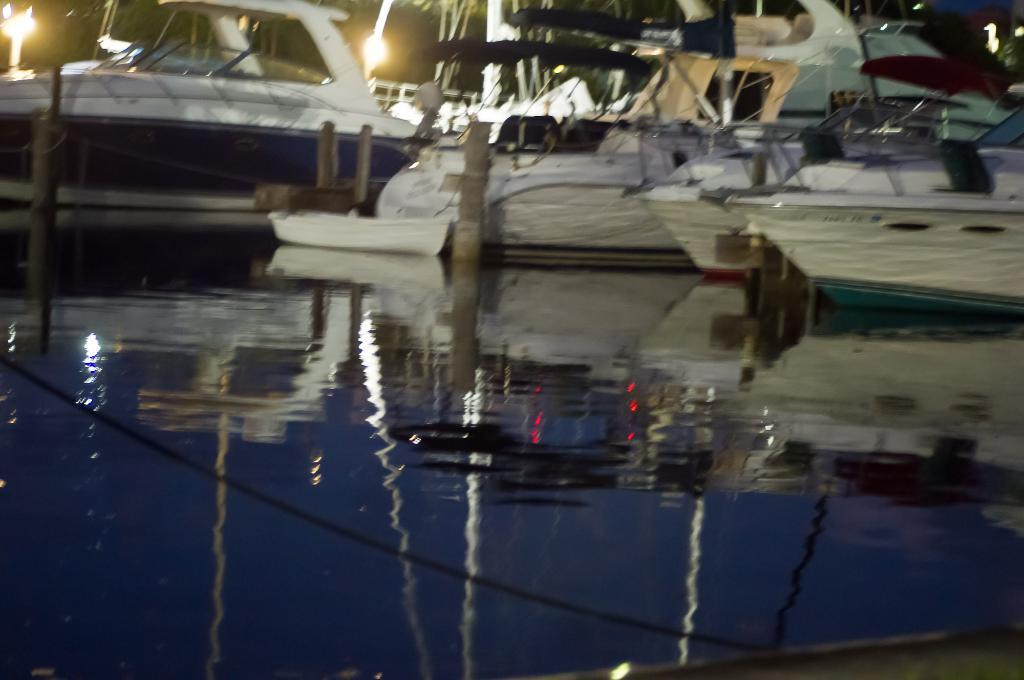What is at the bottom of the image? There is water at the bottom of the image. What can be seen in the water? The reflection of ships is visible in the water. What type of vehicles are present in the image? There are ships with poles in the image. Can you see a ball being played with by a goose in the image? There is no ball or goose present in the image. What type of bun is being used as a sail on the ships in the image? The ships in the image have poles, not buns, as their masts. 